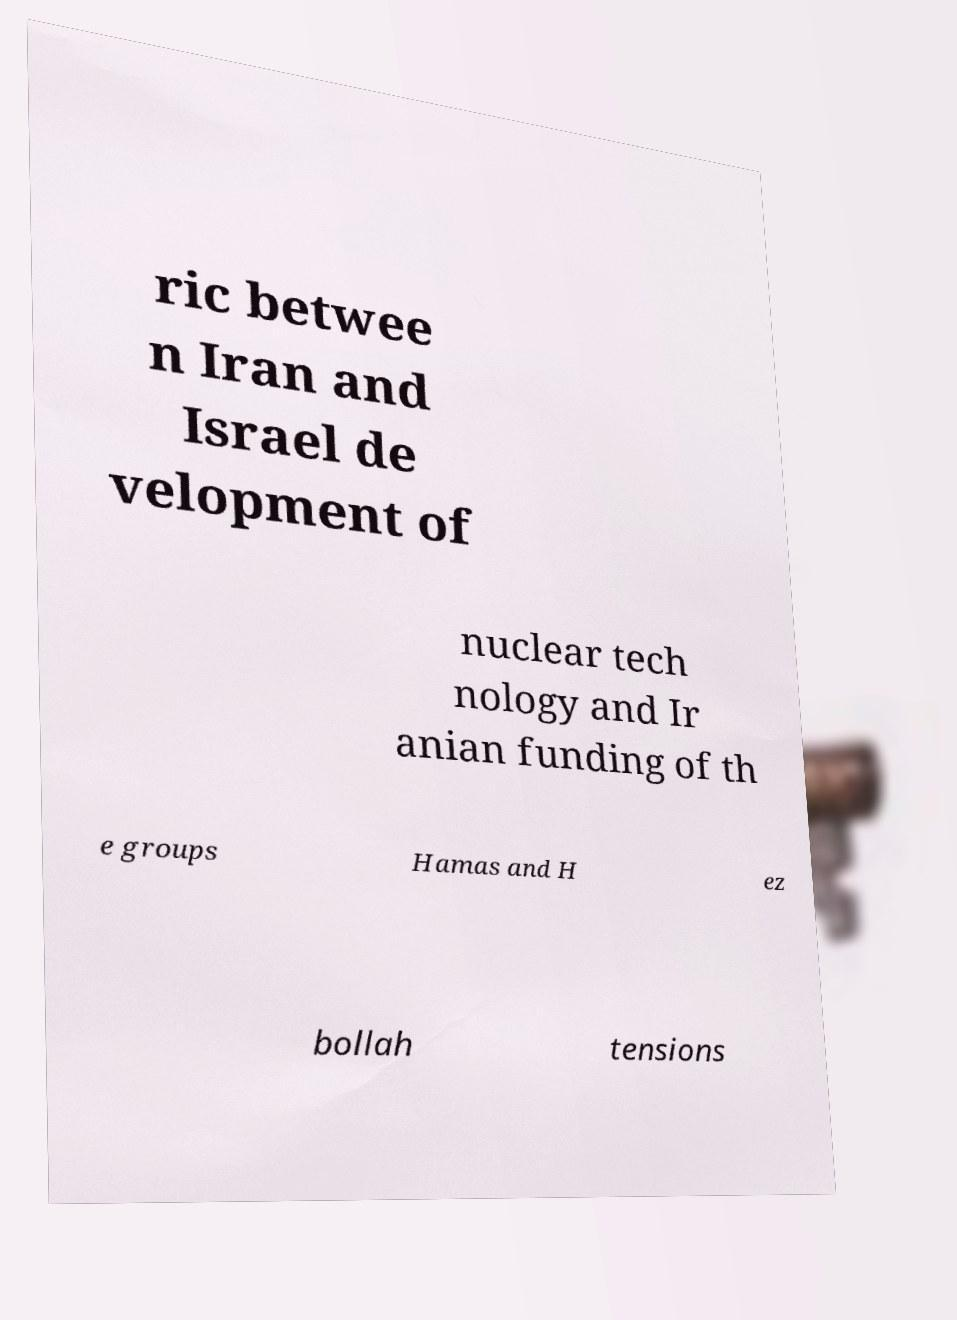There's text embedded in this image that I need extracted. Can you transcribe it verbatim? ric betwee n Iran and Israel de velopment of nuclear tech nology and Ir anian funding of th e groups Hamas and H ez bollah tensions 